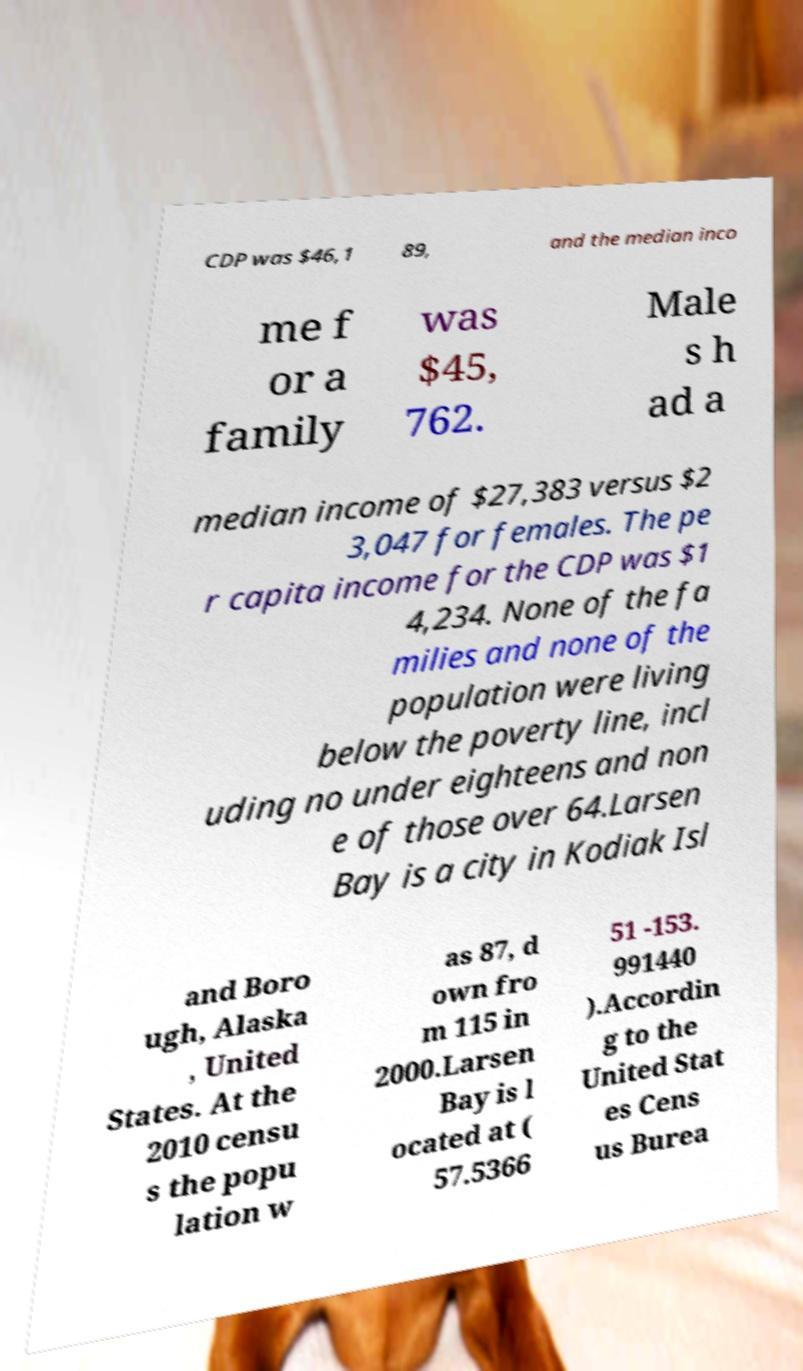For documentation purposes, I need the text within this image transcribed. Could you provide that? CDP was $46,1 89, and the median inco me f or a family was $45, 762. Male s h ad a median income of $27,383 versus $2 3,047 for females. The pe r capita income for the CDP was $1 4,234. None of the fa milies and none of the population were living below the poverty line, incl uding no under eighteens and non e of those over 64.Larsen Bay is a city in Kodiak Isl and Boro ugh, Alaska , United States. At the 2010 censu s the popu lation w as 87, d own fro m 115 in 2000.Larsen Bay is l ocated at ( 57.5366 51 -153. 991440 ).Accordin g to the United Stat es Cens us Burea 